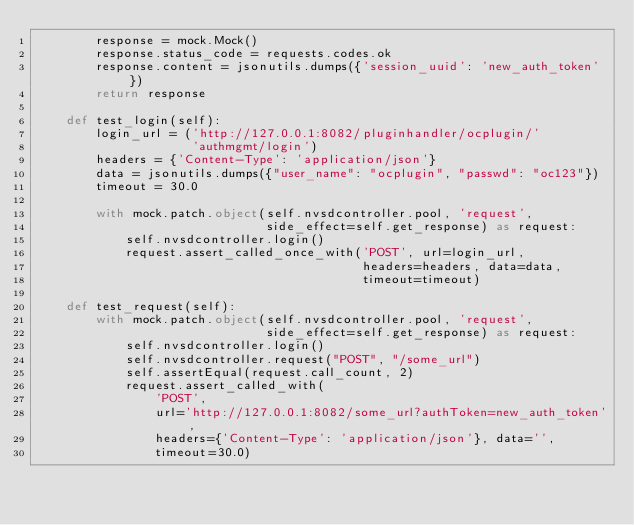Convert code to text. <code><loc_0><loc_0><loc_500><loc_500><_Python_>        response = mock.Mock()
        response.status_code = requests.codes.ok
        response.content = jsonutils.dumps({'session_uuid': 'new_auth_token'})
        return response

    def test_login(self):
        login_url = ('http://127.0.0.1:8082/pluginhandler/ocplugin/'
                     'authmgmt/login')
        headers = {'Content-Type': 'application/json'}
        data = jsonutils.dumps({"user_name": "ocplugin", "passwd": "oc123"})
        timeout = 30.0

        with mock.patch.object(self.nvsdcontroller.pool, 'request',
                               side_effect=self.get_response) as request:
            self.nvsdcontroller.login()
            request.assert_called_once_with('POST', url=login_url,
                                            headers=headers, data=data,
                                            timeout=timeout)

    def test_request(self):
        with mock.patch.object(self.nvsdcontroller.pool, 'request',
                               side_effect=self.get_response) as request:
            self.nvsdcontroller.login()
            self.nvsdcontroller.request("POST", "/some_url")
            self.assertEqual(request.call_count, 2)
            request.assert_called_with(
                'POST',
                url='http://127.0.0.1:8082/some_url?authToken=new_auth_token',
                headers={'Content-Type': 'application/json'}, data='',
                timeout=30.0)
</code> 